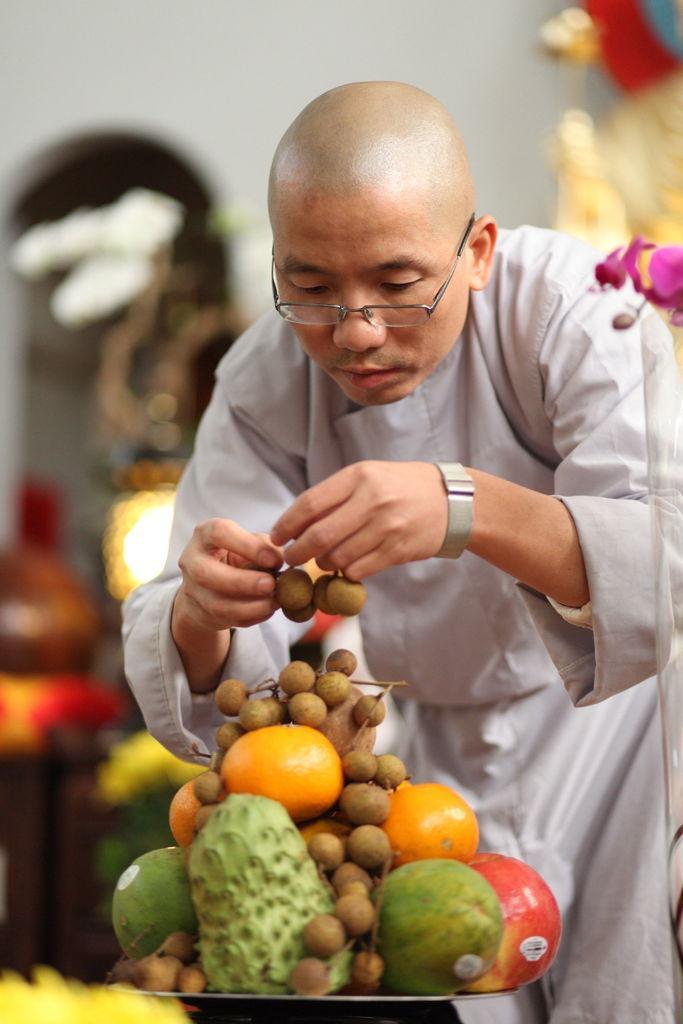Please provide a concise description of this image. In this image there is a plate in that plate there are fruits, behind the plate there is a man standing and holding fruits in his hand, in the background it is blurred. 